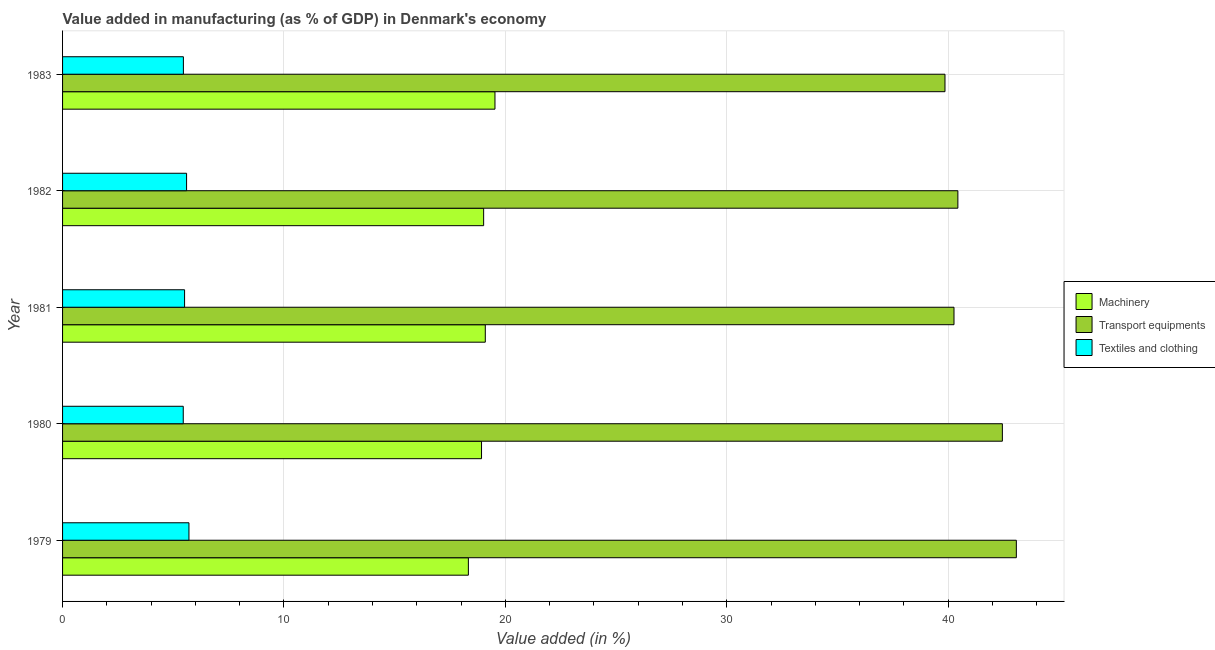Are the number of bars per tick equal to the number of legend labels?
Ensure brevity in your answer.  Yes. What is the label of the 2nd group of bars from the top?
Your response must be concise. 1982. What is the value added in manufacturing textile and clothing in 1979?
Your answer should be very brief. 5.71. Across all years, what is the maximum value added in manufacturing machinery?
Make the answer very short. 19.53. Across all years, what is the minimum value added in manufacturing textile and clothing?
Your response must be concise. 5.45. In which year was the value added in manufacturing transport equipments maximum?
Make the answer very short. 1979. In which year was the value added in manufacturing machinery minimum?
Provide a succinct answer. 1979. What is the total value added in manufacturing transport equipments in the graph?
Give a very brief answer. 206.1. What is the difference between the value added in manufacturing transport equipments in 1981 and that in 1982?
Make the answer very short. -0.17. What is the difference between the value added in manufacturing transport equipments in 1979 and the value added in manufacturing textile and clothing in 1982?
Make the answer very short. 37.48. What is the average value added in manufacturing transport equipments per year?
Your response must be concise. 41.22. In the year 1983, what is the difference between the value added in manufacturing transport equipments and value added in manufacturing machinery?
Ensure brevity in your answer.  20.33. In how many years, is the value added in manufacturing machinery greater than 2 %?
Offer a very short reply. 5. What is the ratio of the value added in manufacturing transport equipments in 1982 to that in 1983?
Keep it short and to the point. 1.01. Is the difference between the value added in manufacturing machinery in 1980 and 1981 greater than the difference between the value added in manufacturing transport equipments in 1980 and 1981?
Provide a short and direct response. No. What is the difference between the highest and the second highest value added in manufacturing transport equipments?
Offer a very short reply. 0.63. What does the 3rd bar from the top in 1980 represents?
Offer a terse response. Machinery. What does the 1st bar from the bottom in 1983 represents?
Keep it short and to the point. Machinery. How many bars are there?
Give a very brief answer. 15. How many years are there in the graph?
Keep it short and to the point. 5. Are the values on the major ticks of X-axis written in scientific E-notation?
Offer a very short reply. No. Does the graph contain any zero values?
Offer a terse response. No. Does the graph contain grids?
Offer a terse response. Yes. Where does the legend appear in the graph?
Offer a terse response. Center right. How many legend labels are there?
Provide a succinct answer. 3. How are the legend labels stacked?
Give a very brief answer. Vertical. What is the title of the graph?
Offer a terse response. Value added in manufacturing (as % of GDP) in Denmark's economy. What is the label or title of the X-axis?
Offer a terse response. Value added (in %). What is the label or title of the Y-axis?
Ensure brevity in your answer.  Year. What is the Value added (in %) of Machinery in 1979?
Ensure brevity in your answer.  18.33. What is the Value added (in %) in Transport equipments in 1979?
Offer a terse response. 43.08. What is the Value added (in %) in Textiles and clothing in 1979?
Ensure brevity in your answer.  5.71. What is the Value added (in %) of Machinery in 1980?
Keep it short and to the point. 18.92. What is the Value added (in %) in Transport equipments in 1980?
Your response must be concise. 42.45. What is the Value added (in %) in Textiles and clothing in 1980?
Offer a very short reply. 5.45. What is the Value added (in %) in Machinery in 1981?
Offer a terse response. 19.09. What is the Value added (in %) of Transport equipments in 1981?
Make the answer very short. 40.27. What is the Value added (in %) in Textiles and clothing in 1981?
Make the answer very short. 5.51. What is the Value added (in %) in Machinery in 1982?
Keep it short and to the point. 19.02. What is the Value added (in %) in Transport equipments in 1982?
Your response must be concise. 40.44. What is the Value added (in %) in Textiles and clothing in 1982?
Your response must be concise. 5.6. What is the Value added (in %) in Machinery in 1983?
Provide a succinct answer. 19.53. What is the Value added (in %) of Transport equipments in 1983?
Your answer should be very brief. 39.86. What is the Value added (in %) of Textiles and clothing in 1983?
Keep it short and to the point. 5.46. Across all years, what is the maximum Value added (in %) of Machinery?
Make the answer very short. 19.53. Across all years, what is the maximum Value added (in %) in Transport equipments?
Offer a terse response. 43.08. Across all years, what is the maximum Value added (in %) of Textiles and clothing?
Provide a short and direct response. 5.71. Across all years, what is the minimum Value added (in %) in Machinery?
Provide a succinct answer. 18.33. Across all years, what is the minimum Value added (in %) of Transport equipments?
Your response must be concise. 39.86. Across all years, what is the minimum Value added (in %) in Textiles and clothing?
Make the answer very short. 5.45. What is the total Value added (in %) in Machinery in the graph?
Provide a succinct answer. 94.9. What is the total Value added (in %) of Transport equipments in the graph?
Your answer should be compact. 206.1. What is the total Value added (in %) in Textiles and clothing in the graph?
Your response must be concise. 27.73. What is the difference between the Value added (in %) in Machinery in 1979 and that in 1980?
Keep it short and to the point. -0.59. What is the difference between the Value added (in %) in Transport equipments in 1979 and that in 1980?
Make the answer very short. 0.63. What is the difference between the Value added (in %) of Textiles and clothing in 1979 and that in 1980?
Provide a succinct answer. 0.26. What is the difference between the Value added (in %) in Machinery in 1979 and that in 1981?
Offer a very short reply. -0.76. What is the difference between the Value added (in %) of Transport equipments in 1979 and that in 1981?
Offer a terse response. 2.82. What is the difference between the Value added (in %) of Textiles and clothing in 1979 and that in 1981?
Keep it short and to the point. 0.2. What is the difference between the Value added (in %) of Machinery in 1979 and that in 1982?
Your response must be concise. -0.69. What is the difference between the Value added (in %) of Transport equipments in 1979 and that in 1982?
Your answer should be compact. 2.64. What is the difference between the Value added (in %) of Textiles and clothing in 1979 and that in 1982?
Give a very brief answer. 0.11. What is the difference between the Value added (in %) in Machinery in 1979 and that in 1983?
Provide a succinct answer. -1.2. What is the difference between the Value added (in %) in Transport equipments in 1979 and that in 1983?
Offer a very short reply. 3.22. What is the difference between the Value added (in %) of Textiles and clothing in 1979 and that in 1983?
Keep it short and to the point. 0.25. What is the difference between the Value added (in %) in Machinery in 1980 and that in 1981?
Provide a succinct answer. -0.17. What is the difference between the Value added (in %) in Transport equipments in 1980 and that in 1981?
Give a very brief answer. 2.19. What is the difference between the Value added (in %) in Textiles and clothing in 1980 and that in 1981?
Provide a succinct answer. -0.06. What is the difference between the Value added (in %) of Machinery in 1980 and that in 1982?
Keep it short and to the point. -0.1. What is the difference between the Value added (in %) in Transport equipments in 1980 and that in 1982?
Keep it short and to the point. 2.01. What is the difference between the Value added (in %) in Textiles and clothing in 1980 and that in 1982?
Give a very brief answer. -0.15. What is the difference between the Value added (in %) of Machinery in 1980 and that in 1983?
Keep it short and to the point. -0.61. What is the difference between the Value added (in %) of Transport equipments in 1980 and that in 1983?
Make the answer very short. 2.59. What is the difference between the Value added (in %) in Textiles and clothing in 1980 and that in 1983?
Offer a very short reply. -0.01. What is the difference between the Value added (in %) of Machinery in 1981 and that in 1982?
Offer a very short reply. 0.07. What is the difference between the Value added (in %) of Transport equipments in 1981 and that in 1982?
Your answer should be very brief. -0.17. What is the difference between the Value added (in %) in Textiles and clothing in 1981 and that in 1982?
Keep it short and to the point. -0.09. What is the difference between the Value added (in %) of Machinery in 1981 and that in 1983?
Provide a short and direct response. -0.44. What is the difference between the Value added (in %) of Transport equipments in 1981 and that in 1983?
Provide a short and direct response. 0.41. What is the difference between the Value added (in %) in Textiles and clothing in 1981 and that in 1983?
Your answer should be compact. 0.05. What is the difference between the Value added (in %) in Machinery in 1982 and that in 1983?
Your response must be concise. -0.51. What is the difference between the Value added (in %) in Transport equipments in 1982 and that in 1983?
Give a very brief answer. 0.58. What is the difference between the Value added (in %) of Textiles and clothing in 1982 and that in 1983?
Keep it short and to the point. 0.14. What is the difference between the Value added (in %) of Machinery in 1979 and the Value added (in %) of Transport equipments in 1980?
Your answer should be very brief. -24.12. What is the difference between the Value added (in %) in Machinery in 1979 and the Value added (in %) in Textiles and clothing in 1980?
Your answer should be compact. 12.88. What is the difference between the Value added (in %) of Transport equipments in 1979 and the Value added (in %) of Textiles and clothing in 1980?
Provide a short and direct response. 37.63. What is the difference between the Value added (in %) of Machinery in 1979 and the Value added (in %) of Transport equipments in 1981?
Offer a very short reply. -21.94. What is the difference between the Value added (in %) in Machinery in 1979 and the Value added (in %) in Textiles and clothing in 1981?
Offer a very short reply. 12.82. What is the difference between the Value added (in %) of Transport equipments in 1979 and the Value added (in %) of Textiles and clothing in 1981?
Your answer should be very brief. 37.57. What is the difference between the Value added (in %) of Machinery in 1979 and the Value added (in %) of Transport equipments in 1982?
Your answer should be very brief. -22.11. What is the difference between the Value added (in %) in Machinery in 1979 and the Value added (in %) in Textiles and clothing in 1982?
Keep it short and to the point. 12.73. What is the difference between the Value added (in %) in Transport equipments in 1979 and the Value added (in %) in Textiles and clothing in 1982?
Offer a very short reply. 37.48. What is the difference between the Value added (in %) of Machinery in 1979 and the Value added (in %) of Transport equipments in 1983?
Provide a short and direct response. -21.53. What is the difference between the Value added (in %) of Machinery in 1979 and the Value added (in %) of Textiles and clothing in 1983?
Offer a terse response. 12.87. What is the difference between the Value added (in %) of Transport equipments in 1979 and the Value added (in %) of Textiles and clothing in 1983?
Give a very brief answer. 37.62. What is the difference between the Value added (in %) in Machinery in 1980 and the Value added (in %) in Transport equipments in 1981?
Offer a very short reply. -21.34. What is the difference between the Value added (in %) in Machinery in 1980 and the Value added (in %) in Textiles and clothing in 1981?
Keep it short and to the point. 13.41. What is the difference between the Value added (in %) in Transport equipments in 1980 and the Value added (in %) in Textiles and clothing in 1981?
Your answer should be very brief. 36.94. What is the difference between the Value added (in %) in Machinery in 1980 and the Value added (in %) in Transport equipments in 1982?
Your answer should be very brief. -21.52. What is the difference between the Value added (in %) of Machinery in 1980 and the Value added (in %) of Textiles and clothing in 1982?
Offer a terse response. 13.32. What is the difference between the Value added (in %) in Transport equipments in 1980 and the Value added (in %) in Textiles and clothing in 1982?
Your response must be concise. 36.85. What is the difference between the Value added (in %) in Machinery in 1980 and the Value added (in %) in Transport equipments in 1983?
Keep it short and to the point. -20.93. What is the difference between the Value added (in %) in Machinery in 1980 and the Value added (in %) in Textiles and clothing in 1983?
Your response must be concise. 13.47. What is the difference between the Value added (in %) of Transport equipments in 1980 and the Value added (in %) of Textiles and clothing in 1983?
Ensure brevity in your answer.  36.99. What is the difference between the Value added (in %) in Machinery in 1981 and the Value added (in %) in Transport equipments in 1982?
Your response must be concise. -21.35. What is the difference between the Value added (in %) in Machinery in 1981 and the Value added (in %) in Textiles and clothing in 1982?
Give a very brief answer. 13.49. What is the difference between the Value added (in %) of Transport equipments in 1981 and the Value added (in %) of Textiles and clothing in 1982?
Keep it short and to the point. 34.66. What is the difference between the Value added (in %) in Machinery in 1981 and the Value added (in %) in Transport equipments in 1983?
Make the answer very short. -20.76. What is the difference between the Value added (in %) in Machinery in 1981 and the Value added (in %) in Textiles and clothing in 1983?
Provide a succinct answer. 13.64. What is the difference between the Value added (in %) of Transport equipments in 1981 and the Value added (in %) of Textiles and clothing in 1983?
Keep it short and to the point. 34.81. What is the difference between the Value added (in %) of Machinery in 1982 and the Value added (in %) of Transport equipments in 1983?
Make the answer very short. -20.84. What is the difference between the Value added (in %) in Machinery in 1982 and the Value added (in %) in Textiles and clothing in 1983?
Your answer should be compact. 13.56. What is the difference between the Value added (in %) in Transport equipments in 1982 and the Value added (in %) in Textiles and clothing in 1983?
Your answer should be compact. 34.98. What is the average Value added (in %) of Machinery per year?
Give a very brief answer. 18.98. What is the average Value added (in %) in Transport equipments per year?
Make the answer very short. 41.22. What is the average Value added (in %) in Textiles and clothing per year?
Your answer should be compact. 5.55. In the year 1979, what is the difference between the Value added (in %) of Machinery and Value added (in %) of Transport equipments?
Your response must be concise. -24.75. In the year 1979, what is the difference between the Value added (in %) in Machinery and Value added (in %) in Textiles and clothing?
Your answer should be very brief. 12.62. In the year 1979, what is the difference between the Value added (in %) in Transport equipments and Value added (in %) in Textiles and clothing?
Ensure brevity in your answer.  37.37. In the year 1980, what is the difference between the Value added (in %) in Machinery and Value added (in %) in Transport equipments?
Offer a terse response. -23.53. In the year 1980, what is the difference between the Value added (in %) of Machinery and Value added (in %) of Textiles and clothing?
Offer a very short reply. 13.47. In the year 1980, what is the difference between the Value added (in %) of Transport equipments and Value added (in %) of Textiles and clothing?
Keep it short and to the point. 37. In the year 1981, what is the difference between the Value added (in %) in Machinery and Value added (in %) in Transport equipments?
Keep it short and to the point. -21.17. In the year 1981, what is the difference between the Value added (in %) of Machinery and Value added (in %) of Textiles and clothing?
Ensure brevity in your answer.  13.58. In the year 1981, what is the difference between the Value added (in %) in Transport equipments and Value added (in %) in Textiles and clothing?
Offer a very short reply. 34.75. In the year 1982, what is the difference between the Value added (in %) of Machinery and Value added (in %) of Transport equipments?
Make the answer very short. -21.42. In the year 1982, what is the difference between the Value added (in %) in Machinery and Value added (in %) in Textiles and clothing?
Your answer should be compact. 13.42. In the year 1982, what is the difference between the Value added (in %) of Transport equipments and Value added (in %) of Textiles and clothing?
Your answer should be very brief. 34.84. In the year 1983, what is the difference between the Value added (in %) in Machinery and Value added (in %) in Transport equipments?
Keep it short and to the point. -20.33. In the year 1983, what is the difference between the Value added (in %) of Machinery and Value added (in %) of Textiles and clothing?
Ensure brevity in your answer.  14.07. In the year 1983, what is the difference between the Value added (in %) of Transport equipments and Value added (in %) of Textiles and clothing?
Keep it short and to the point. 34.4. What is the ratio of the Value added (in %) in Machinery in 1979 to that in 1980?
Provide a succinct answer. 0.97. What is the ratio of the Value added (in %) in Transport equipments in 1979 to that in 1980?
Ensure brevity in your answer.  1.01. What is the ratio of the Value added (in %) of Textiles and clothing in 1979 to that in 1980?
Offer a terse response. 1.05. What is the ratio of the Value added (in %) of Transport equipments in 1979 to that in 1981?
Give a very brief answer. 1.07. What is the ratio of the Value added (in %) of Textiles and clothing in 1979 to that in 1981?
Your answer should be compact. 1.04. What is the ratio of the Value added (in %) of Machinery in 1979 to that in 1982?
Your response must be concise. 0.96. What is the ratio of the Value added (in %) of Transport equipments in 1979 to that in 1982?
Ensure brevity in your answer.  1.07. What is the ratio of the Value added (in %) of Textiles and clothing in 1979 to that in 1982?
Your answer should be very brief. 1.02. What is the ratio of the Value added (in %) in Machinery in 1979 to that in 1983?
Your response must be concise. 0.94. What is the ratio of the Value added (in %) in Transport equipments in 1979 to that in 1983?
Your answer should be very brief. 1.08. What is the ratio of the Value added (in %) in Textiles and clothing in 1979 to that in 1983?
Your answer should be compact. 1.05. What is the ratio of the Value added (in %) of Transport equipments in 1980 to that in 1981?
Keep it short and to the point. 1.05. What is the ratio of the Value added (in %) in Machinery in 1980 to that in 1982?
Offer a very short reply. 0.99. What is the ratio of the Value added (in %) of Transport equipments in 1980 to that in 1982?
Keep it short and to the point. 1.05. What is the ratio of the Value added (in %) of Textiles and clothing in 1980 to that in 1982?
Your response must be concise. 0.97. What is the ratio of the Value added (in %) of Machinery in 1980 to that in 1983?
Offer a very short reply. 0.97. What is the ratio of the Value added (in %) of Transport equipments in 1980 to that in 1983?
Your response must be concise. 1.06. What is the ratio of the Value added (in %) in Transport equipments in 1981 to that in 1982?
Provide a short and direct response. 1. What is the ratio of the Value added (in %) in Textiles and clothing in 1981 to that in 1982?
Give a very brief answer. 0.98. What is the ratio of the Value added (in %) in Machinery in 1981 to that in 1983?
Ensure brevity in your answer.  0.98. What is the ratio of the Value added (in %) of Transport equipments in 1981 to that in 1983?
Ensure brevity in your answer.  1.01. What is the ratio of the Value added (in %) in Textiles and clothing in 1981 to that in 1983?
Keep it short and to the point. 1.01. What is the ratio of the Value added (in %) of Machinery in 1982 to that in 1983?
Offer a very short reply. 0.97. What is the ratio of the Value added (in %) in Transport equipments in 1982 to that in 1983?
Provide a succinct answer. 1.01. What is the ratio of the Value added (in %) in Textiles and clothing in 1982 to that in 1983?
Offer a terse response. 1.03. What is the difference between the highest and the second highest Value added (in %) of Machinery?
Your answer should be very brief. 0.44. What is the difference between the highest and the second highest Value added (in %) in Transport equipments?
Give a very brief answer. 0.63. What is the difference between the highest and the second highest Value added (in %) of Textiles and clothing?
Ensure brevity in your answer.  0.11. What is the difference between the highest and the lowest Value added (in %) in Machinery?
Your answer should be very brief. 1.2. What is the difference between the highest and the lowest Value added (in %) of Transport equipments?
Give a very brief answer. 3.22. What is the difference between the highest and the lowest Value added (in %) in Textiles and clothing?
Keep it short and to the point. 0.26. 